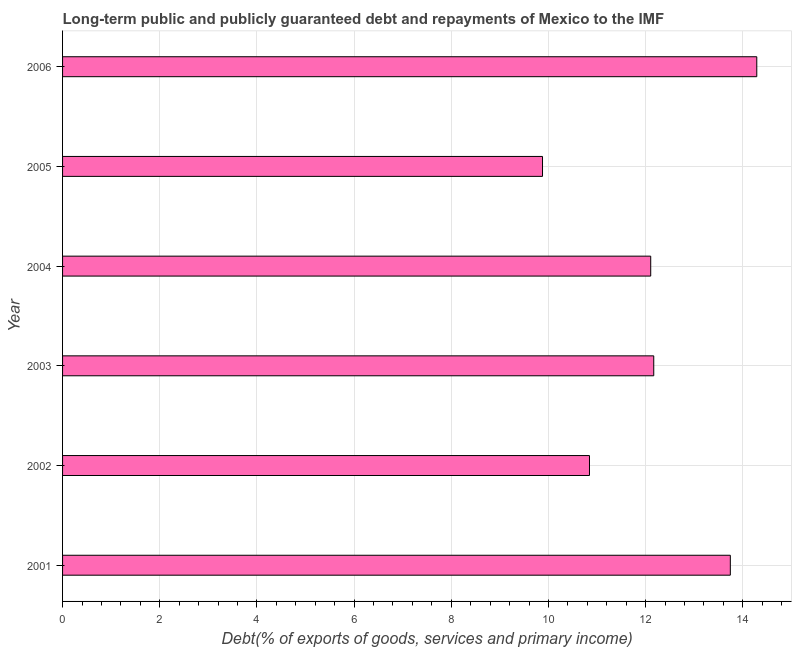What is the title of the graph?
Your answer should be very brief. Long-term public and publicly guaranteed debt and repayments of Mexico to the IMF. What is the label or title of the X-axis?
Keep it short and to the point. Debt(% of exports of goods, services and primary income). What is the label or title of the Y-axis?
Give a very brief answer. Year. What is the debt service in 2006?
Your answer should be very brief. 14.29. Across all years, what is the maximum debt service?
Make the answer very short. 14.29. Across all years, what is the minimum debt service?
Make the answer very short. 9.88. In which year was the debt service minimum?
Your answer should be compact. 2005. What is the sum of the debt service?
Your answer should be very brief. 73.02. What is the difference between the debt service in 2003 and 2004?
Keep it short and to the point. 0.06. What is the average debt service per year?
Your response must be concise. 12.17. What is the median debt service?
Make the answer very short. 12.14. In how many years, is the debt service greater than 4 %?
Provide a succinct answer. 6. Do a majority of the years between 2001 and 2005 (inclusive) have debt service greater than 10.4 %?
Provide a succinct answer. Yes. What is the ratio of the debt service in 2003 to that in 2006?
Keep it short and to the point. 0.85. Is the difference between the debt service in 2003 and 2004 greater than the difference between any two years?
Your answer should be compact. No. What is the difference between the highest and the second highest debt service?
Offer a terse response. 0.54. What is the difference between the highest and the lowest debt service?
Keep it short and to the point. 4.41. Are all the bars in the graph horizontal?
Make the answer very short. Yes. What is the difference between two consecutive major ticks on the X-axis?
Provide a short and direct response. 2. What is the Debt(% of exports of goods, services and primary income) of 2001?
Keep it short and to the point. 13.74. What is the Debt(% of exports of goods, services and primary income) in 2002?
Make the answer very short. 10.84. What is the Debt(% of exports of goods, services and primary income) of 2003?
Your answer should be compact. 12.17. What is the Debt(% of exports of goods, services and primary income) of 2004?
Provide a succinct answer. 12.1. What is the Debt(% of exports of goods, services and primary income) of 2005?
Your answer should be very brief. 9.88. What is the Debt(% of exports of goods, services and primary income) in 2006?
Your answer should be very brief. 14.29. What is the difference between the Debt(% of exports of goods, services and primary income) in 2001 and 2002?
Give a very brief answer. 2.9. What is the difference between the Debt(% of exports of goods, services and primary income) in 2001 and 2003?
Give a very brief answer. 1.58. What is the difference between the Debt(% of exports of goods, services and primary income) in 2001 and 2004?
Make the answer very short. 1.64. What is the difference between the Debt(% of exports of goods, services and primary income) in 2001 and 2005?
Provide a short and direct response. 3.87. What is the difference between the Debt(% of exports of goods, services and primary income) in 2001 and 2006?
Your answer should be compact. -0.54. What is the difference between the Debt(% of exports of goods, services and primary income) in 2002 and 2003?
Make the answer very short. -1.32. What is the difference between the Debt(% of exports of goods, services and primary income) in 2002 and 2004?
Your answer should be very brief. -1.26. What is the difference between the Debt(% of exports of goods, services and primary income) in 2002 and 2005?
Offer a terse response. 0.97. What is the difference between the Debt(% of exports of goods, services and primary income) in 2002 and 2006?
Offer a very short reply. -3.44. What is the difference between the Debt(% of exports of goods, services and primary income) in 2003 and 2004?
Make the answer very short. 0.06. What is the difference between the Debt(% of exports of goods, services and primary income) in 2003 and 2005?
Keep it short and to the point. 2.29. What is the difference between the Debt(% of exports of goods, services and primary income) in 2003 and 2006?
Provide a short and direct response. -2.12. What is the difference between the Debt(% of exports of goods, services and primary income) in 2004 and 2005?
Your answer should be compact. 2.23. What is the difference between the Debt(% of exports of goods, services and primary income) in 2004 and 2006?
Give a very brief answer. -2.18. What is the difference between the Debt(% of exports of goods, services and primary income) in 2005 and 2006?
Keep it short and to the point. -4.41. What is the ratio of the Debt(% of exports of goods, services and primary income) in 2001 to that in 2002?
Offer a very short reply. 1.27. What is the ratio of the Debt(% of exports of goods, services and primary income) in 2001 to that in 2003?
Offer a very short reply. 1.13. What is the ratio of the Debt(% of exports of goods, services and primary income) in 2001 to that in 2004?
Offer a terse response. 1.14. What is the ratio of the Debt(% of exports of goods, services and primary income) in 2001 to that in 2005?
Provide a short and direct response. 1.39. What is the ratio of the Debt(% of exports of goods, services and primary income) in 2001 to that in 2006?
Your answer should be very brief. 0.96. What is the ratio of the Debt(% of exports of goods, services and primary income) in 2002 to that in 2003?
Your response must be concise. 0.89. What is the ratio of the Debt(% of exports of goods, services and primary income) in 2002 to that in 2004?
Your response must be concise. 0.9. What is the ratio of the Debt(% of exports of goods, services and primary income) in 2002 to that in 2005?
Your answer should be very brief. 1.1. What is the ratio of the Debt(% of exports of goods, services and primary income) in 2002 to that in 2006?
Make the answer very short. 0.76. What is the ratio of the Debt(% of exports of goods, services and primary income) in 2003 to that in 2004?
Keep it short and to the point. 1. What is the ratio of the Debt(% of exports of goods, services and primary income) in 2003 to that in 2005?
Your answer should be compact. 1.23. What is the ratio of the Debt(% of exports of goods, services and primary income) in 2003 to that in 2006?
Ensure brevity in your answer.  0.85. What is the ratio of the Debt(% of exports of goods, services and primary income) in 2004 to that in 2005?
Give a very brief answer. 1.23. What is the ratio of the Debt(% of exports of goods, services and primary income) in 2004 to that in 2006?
Your response must be concise. 0.85. What is the ratio of the Debt(% of exports of goods, services and primary income) in 2005 to that in 2006?
Give a very brief answer. 0.69. 